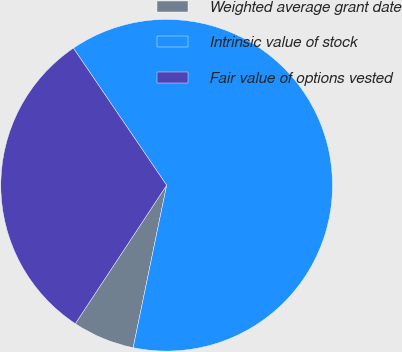Convert chart. <chart><loc_0><loc_0><loc_500><loc_500><pie_chart><fcel>Weighted average grant date<fcel>Intrinsic value of stock<fcel>Fair value of options vested<nl><fcel>6.05%<fcel>62.74%<fcel>31.21%<nl></chart> 